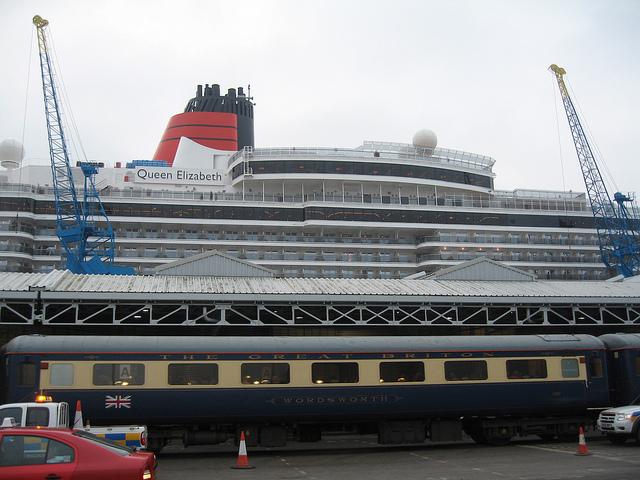Is there a flag on the train?
Write a very short answer. Yes. What color is the car?
Quick response, please. Red. What does the print on the says?
Answer briefly. Queen elizabeth. What is written on the boat?
Give a very brief answer. Queen elizabeth. How many smoke stacks are there?
Quick response, please. 1. 